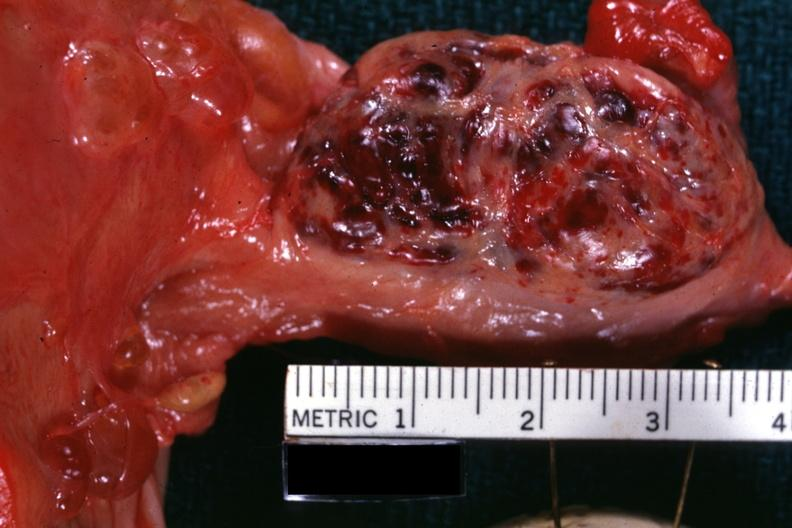s this myoma a corpus luteum from photo?
Answer the question using a single word or phrase. No 